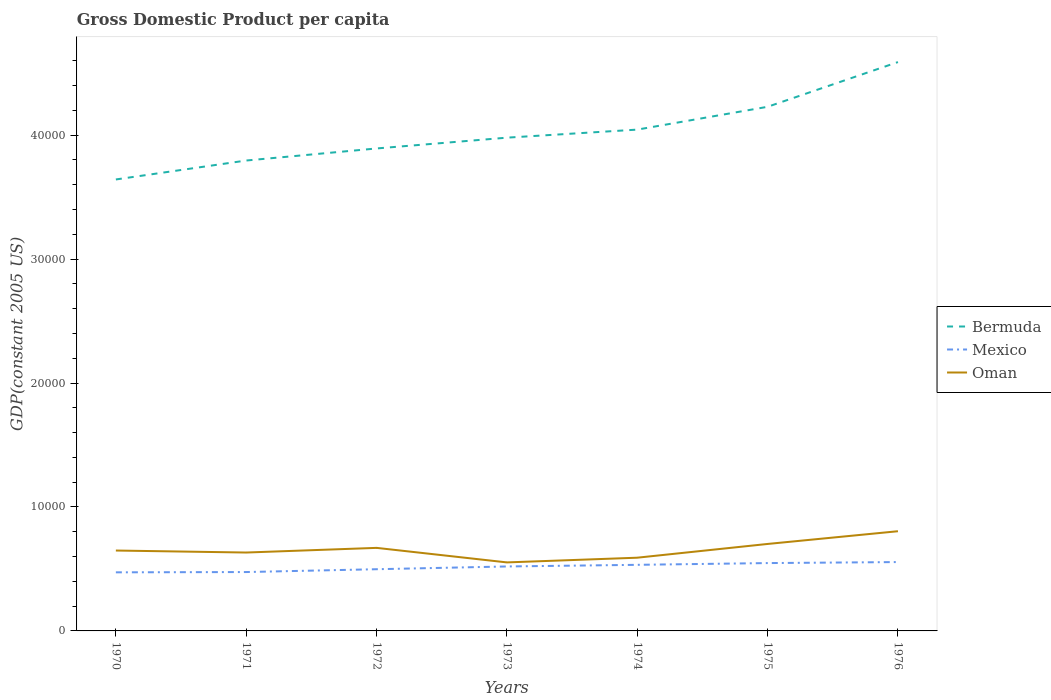Across all years, what is the maximum GDP per capita in Bermuda?
Your answer should be very brief. 3.64e+04. What is the total GDP per capita in Oman in the graph?
Offer a very short reply. 957.95. What is the difference between the highest and the second highest GDP per capita in Bermuda?
Keep it short and to the point. 9469.38. Are the values on the major ticks of Y-axis written in scientific E-notation?
Offer a terse response. No. Where does the legend appear in the graph?
Your response must be concise. Center right. How many legend labels are there?
Keep it short and to the point. 3. How are the legend labels stacked?
Offer a terse response. Vertical. What is the title of the graph?
Provide a short and direct response. Gross Domestic Product per capita. Does "Uganda" appear as one of the legend labels in the graph?
Your answer should be compact. No. What is the label or title of the Y-axis?
Ensure brevity in your answer.  GDP(constant 2005 US). What is the GDP(constant 2005 US) of Bermuda in 1970?
Offer a terse response. 3.64e+04. What is the GDP(constant 2005 US) in Mexico in 1970?
Ensure brevity in your answer.  4726.59. What is the GDP(constant 2005 US) in Oman in 1970?
Your answer should be very brief. 6485.56. What is the GDP(constant 2005 US) in Bermuda in 1971?
Ensure brevity in your answer.  3.80e+04. What is the GDP(constant 2005 US) of Mexico in 1971?
Your answer should be compact. 4750.16. What is the GDP(constant 2005 US) of Oman in 1971?
Provide a succinct answer. 6324.33. What is the GDP(constant 2005 US) of Bermuda in 1972?
Make the answer very short. 3.89e+04. What is the GDP(constant 2005 US) in Mexico in 1972?
Provide a succinct answer. 4977.9. What is the GDP(constant 2005 US) of Oman in 1972?
Your answer should be very brief. 6700.51. What is the GDP(constant 2005 US) of Bermuda in 1973?
Keep it short and to the point. 3.98e+04. What is the GDP(constant 2005 US) of Mexico in 1973?
Provide a succinct answer. 5200.2. What is the GDP(constant 2005 US) in Oman in 1973?
Give a very brief answer. 5527.62. What is the GDP(constant 2005 US) in Bermuda in 1974?
Provide a short and direct response. 4.04e+04. What is the GDP(constant 2005 US) in Mexico in 1974?
Keep it short and to the point. 5332.38. What is the GDP(constant 2005 US) of Oman in 1974?
Give a very brief answer. 5907.33. What is the GDP(constant 2005 US) of Bermuda in 1975?
Keep it short and to the point. 4.23e+04. What is the GDP(constant 2005 US) of Mexico in 1975?
Offer a terse response. 5473.64. What is the GDP(constant 2005 US) in Oman in 1975?
Your response must be concise. 7016.54. What is the GDP(constant 2005 US) of Bermuda in 1976?
Your answer should be very brief. 4.59e+04. What is the GDP(constant 2005 US) in Mexico in 1976?
Offer a terse response. 5555.92. What is the GDP(constant 2005 US) in Oman in 1976?
Give a very brief answer. 8043.76. Across all years, what is the maximum GDP(constant 2005 US) of Bermuda?
Your answer should be compact. 4.59e+04. Across all years, what is the maximum GDP(constant 2005 US) in Mexico?
Provide a succinct answer. 5555.92. Across all years, what is the maximum GDP(constant 2005 US) in Oman?
Provide a short and direct response. 8043.76. Across all years, what is the minimum GDP(constant 2005 US) in Bermuda?
Make the answer very short. 3.64e+04. Across all years, what is the minimum GDP(constant 2005 US) in Mexico?
Ensure brevity in your answer.  4726.59. Across all years, what is the minimum GDP(constant 2005 US) of Oman?
Your answer should be very brief. 5527.62. What is the total GDP(constant 2005 US) of Bermuda in the graph?
Give a very brief answer. 2.82e+05. What is the total GDP(constant 2005 US) in Mexico in the graph?
Offer a very short reply. 3.60e+04. What is the total GDP(constant 2005 US) in Oman in the graph?
Your response must be concise. 4.60e+04. What is the difference between the GDP(constant 2005 US) of Bermuda in 1970 and that in 1971?
Ensure brevity in your answer.  -1528.03. What is the difference between the GDP(constant 2005 US) of Mexico in 1970 and that in 1971?
Your answer should be very brief. -23.57. What is the difference between the GDP(constant 2005 US) of Oman in 1970 and that in 1971?
Your answer should be very brief. 161.23. What is the difference between the GDP(constant 2005 US) of Bermuda in 1970 and that in 1972?
Your response must be concise. -2501.12. What is the difference between the GDP(constant 2005 US) of Mexico in 1970 and that in 1972?
Offer a very short reply. -251.31. What is the difference between the GDP(constant 2005 US) in Oman in 1970 and that in 1972?
Make the answer very short. -214.95. What is the difference between the GDP(constant 2005 US) of Bermuda in 1970 and that in 1973?
Your response must be concise. -3372.31. What is the difference between the GDP(constant 2005 US) in Mexico in 1970 and that in 1973?
Provide a succinct answer. -473.61. What is the difference between the GDP(constant 2005 US) in Oman in 1970 and that in 1973?
Ensure brevity in your answer.  957.95. What is the difference between the GDP(constant 2005 US) in Bermuda in 1970 and that in 1974?
Your response must be concise. -4022.09. What is the difference between the GDP(constant 2005 US) in Mexico in 1970 and that in 1974?
Offer a very short reply. -605.8. What is the difference between the GDP(constant 2005 US) in Oman in 1970 and that in 1974?
Provide a short and direct response. 578.24. What is the difference between the GDP(constant 2005 US) in Bermuda in 1970 and that in 1975?
Your response must be concise. -5862.84. What is the difference between the GDP(constant 2005 US) in Mexico in 1970 and that in 1975?
Make the answer very short. -747.05. What is the difference between the GDP(constant 2005 US) in Oman in 1970 and that in 1975?
Provide a short and direct response. -530.98. What is the difference between the GDP(constant 2005 US) in Bermuda in 1970 and that in 1976?
Provide a short and direct response. -9469.38. What is the difference between the GDP(constant 2005 US) of Mexico in 1970 and that in 1976?
Provide a short and direct response. -829.33. What is the difference between the GDP(constant 2005 US) of Oman in 1970 and that in 1976?
Provide a short and direct response. -1558.2. What is the difference between the GDP(constant 2005 US) of Bermuda in 1971 and that in 1972?
Provide a succinct answer. -973.08. What is the difference between the GDP(constant 2005 US) of Mexico in 1971 and that in 1972?
Your answer should be compact. -227.74. What is the difference between the GDP(constant 2005 US) in Oman in 1971 and that in 1972?
Give a very brief answer. -376.18. What is the difference between the GDP(constant 2005 US) of Bermuda in 1971 and that in 1973?
Your answer should be very brief. -1844.28. What is the difference between the GDP(constant 2005 US) of Mexico in 1971 and that in 1973?
Your response must be concise. -450.04. What is the difference between the GDP(constant 2005 US) in Oman in 1971 and that in 1973?
Ensure brevity in your answer.  796.72. What is the difference between the GDP(constant 2005 US) of Bermuda in 1971 and that in 1974?
Keep it short and to the point. -2494.06. What is the difference between the GDP(constant 2005 US) of Mexico in 1971 and that in 1974?
Ensure brevity in your answer.  -582.22. What is the difference between the GDP(constant 2005 US) in Oman in 1971 and that in 1974?
Give a very brief answer. 417.01. What is the difference between the GDP(constant 2005 US) of Bermuda in 1971 and that in 1975?
Offer a terse response. -4334.81. What is the difference between the GDP(constant 2005 US) in Mexico in 1971 and that in 1975?
Offer a terse response. -723.48. What is the difference between the GDP(constant 2005 US) of Oman in 1971 and that in 1975?
Offer a very short reply. -692.2. What is the difference between the GDP(constant 2005 US) of Bermuda in 1971 and that in 1976?
Your response must be concise. -7941.34. What is the difference between the GDP(constant 2005 US) in Mexico in 1971 and that in 1976?
Keep it short and to the point. -805.76. What is the difference between the GDP(constant 2005 US) of Oman in 1971 and that in 1976?
Keep it short and to the point. -1719.43. What is the difference between the GDP(constant 2005 US) of Bermuda in 1972 and that in 1973?
Provide a short and direct response. -871.19. What is the difference between the GDP(constant 2005 US) of Mexico in 1972 and that in 1973?
Make the answer very short. -222.3. What is the difference between the GDP(constant 2005 US) of Oman in 1972 and that in 1973?
Keep it short and to the point. 1172.9. What is the difference between the GDP(constant 2005 US) in Bermuda in 1972 and that in 1974?
Your answer should be compact. -1520.98. What is the difference between the GDP(constant 2005 US) of Mexico in 1972 and that in 1974?
Make the answer very short. -354.48. What is the difference between the GDP(constant 2005 US) of Oman in 1972 and that in 1974?
Ensure brevity in your answer.  793.19. What is the difference between the GDP(constant 2005 US) in Bermuda in 1972 and that in 1975?
Ensure brevity in your answer.  -3361.73. What is the difference between the GDP(constant 2005 US) in Mexico in 1972 and that in 1975?
Provide a short and direct response. -495.74. What is the difference between the GDP(constant 2005 US) in Oman in 1972 and that in 1975?
Offer a terse response. -316.02. What is the difference between the GDP(constant 2005 US) in Bermuda in 1972 and that in 1976?
Your answer should be very brief. -6968.26. What is the difference between the GDP(constant 2005 US) in Mexico in 1972 and that in 1976?
Your answer should be very brief. -578.02. What is the difference between the GDP(constant 2005 US) of Oman in 1972 and that in 1976?
Your answer should be very brief. -1343.25. What is the difference between the GDP(constant 2005 US) of Bermuda in 1973 and that in 1974?
Your answer should be compact. -649.78. What is the difference between the GDP(constant 2005 US) of Mexico in 1973 and that in 1974?
Your response must be concise. -132.18. What is the difference between the GDP(constant 2005 US) in Oman in 1973 and that in 1974?
Keep it short and to the point. -379.71. What is the difference between the GDP(constant 2005 US) of Bermuda in 1973 and that in 1975?
Provide a succinct answer. -2490.53. What is the difference between the GDP(constant 2005 US) of Mexico in 1973 and that in 1975?
Your answer should be compact. -273.44. What is the difference between the GDP(constant 2005 US) of Oman in 1973 and that in 1975?
Give a very brief answer. -1488.92. What is the difference between the GDP(constant 2005 US) of Bermuda in 1973 and that in 1976?
Your answer should be compact. -6097.07. What is the difference between the GDP(constant 2005 US) in Mexico in 1973 and that in 1976?
Provide a succinct answer. -355.72. What is the difference between the GDP(constant 2005 US) in Oman in 1973 and that in 1976?
Your answer should be very brief. -2516.15. What is the difference between the GDP(constant 2005 US) of Bermuda in 1974 and that in 1975?
Provide a short and direct response. -1840.75. What is the difference between the GDP(constant 2005 US) of Mexico in 1974 and that in 1975?
Offer a very short reply. -141.26. What is the difference between the GDP(constant 2005 US) of Oman in 1974 and that in 1975?
Keep it short and to the point. -1109.21. What is the difference between the GDP(constant 2005 US) of Bermuda in 1974 and that in 1976?
Your response must be concise. -5447.28. What is the difference between the GDP(constant 2005 US) of Mexico in 1974 and that in 1976?
Make the answer very short. -223.54. What is the difference between the GDP(constant 2005 US) in Oman in 1974 and that in 1976?
Give a very brief answer. -2136.44. What is the difference between the GDP(constant 2005 US) of Bermuda in 1975 and that in 1976?
Give a very brief answer. -3606.53. What is the difference between the GDP(constant 2005 US) of Mexico in 1975 and that in 1976?
Keep it short and to the point. -82.28. What is the difference between the GDP(constant 2005 US) in Oman in 1975 and that in 1976?
Your response must be concise. -1027.23. What is the difference between the GDP(constant 2005 US) of Bermuda in 1970 and the GDP(constant 2005 US) of Mexico in 1971?
Offer a very short reply. 3.17e+04. What is the difference between the GDP(constant 2005 US) of Bermuda in 1970 and the GDP(constant 2005 US) of Oman in 1971?
Offer a very short reply. 3.01e+04. What is the difference between the GDP(constant 2005 US) of Mexico in 1970 and the GDP(constant 2005 US) of Oman in 1971?
Keep it short and to the point. -1597.75. What is the difference between the GDP(constant 2005 US) in Bermuda in 1970 and the GDP(constant 2005 US) in Mexico in 1972?
Offer a terse response. 3.14e+04. What is the difference between the GDP(constant 2005 US) of Bermuda in 1970 and the GDP(constant 2005 US) of Oman in 1972?
Your response must be concise. 2.97e+04. What is the difference between the GDP(constant 2005 US) in Mexico in 1970 and the GDP(constant 2005 US) in Oman in 1972?
Keep it short and to the point. -1973.93. What is the difference between the GDP(constant 2005 US) of Bermuda in 1970 and the GDP(constant 2005 US) of Mexico in 1973?
Ensure brevity in your answer.  3.12e+04. What is the difference between the GDP(constant 2005 US) in Bermuda in 1970 and the GDP(constant 2005 US) in Oman in 1973?
Provide a succinct answer. 3.09e+04. What is the difference between the GDP(constant 2005 US) in Mexico in 1970 and the GDP(constant 2005 US) in Oman in 1973?
Offer a terse response. -801.03. What is the difference between the GDP(constant 2005 US) of Bermuda in 1970 and the GDP(constant 2005 US) of Mexico in 1974?
Your answer should be very brief. 3.11e+04. What is the difference between the GDP(constant 2005 US) in Bermuda in 1970 and the GDP(constant 2005 US) in Oman in 1974?
Your response must be concise. 3.05e+04. What is the difference between the GDP(constant 2005 US) of Mexico in 1970 and the GDP(constant 2005 US) of Oman in 1974?
Ensure brevity in your answer.  -1180.74. What is the difference between the GDP(constant 2005 US) in Bermuda in 1970 and the GDP(constant 2005 US) in Mexico in 1975?
Provide a short and direct response. 3.09e+04. What is the difference between the GDP(constant 2005 US) of Bermuda in 1970 and the GDP(constant 2005 US) of Oman in 1975?
Offer a terse response. 2.94e+04. What is the difference between the GDP(constant 2005 US) in Mexico in 1970 and the GDP(constant 2005 US) in Oman in 1975?
Your answer should be compact. -2289.95. What is the difference between the GDP(constant 2005 US) in Bermuda in 1970 and the GDP(constant 2005 US) in Mexico in 1976?
Ensure brevity in your answer.  3.09e+04. What is the difference between the GDP(constant 2005 US) of Bermuda in 1970 and the GDP(constant 2005 US) of Oman in 1976?
Provide a succinct answer. 2.84e+04. What is the difference between the GDP(constant 2005 US) in Mexico in 1970 and the GDP(constant 2005 US) in Oman in 1976?
Provide a succinct answer. -3317.18. What is the difference between the GDP(constant 2005 US) of Bermuda in 1971 and the GDP(constant 2005 US) of Mexico in 1972?
Offer a terse response. 3.30e+04. What is the difference between the GDP(constant 2005 US) in Bermuda in 1971 and the GDP(constant 2005 US) in Oman in 1972?
Your answer should be compact. 3.13e+04. What is the difference between the GDP(constant 2005 US) in Mexico in 1971 and the GDP(constant 2005 US) in Oman in 1972?
Provide a succinct answer. -1950.35. What is the difference between the GDP(constant 2005 US) of Bermuda in 1971 and the GDP(constant 2005 US) of Mexico in 1973?
Keep it short and to the point. 3.28e+04. What is the difference between the GDP(constant 2005 US) in Bermuda in 1971 and the GDP(constant 2005 US) in Oman in 1973?
Your response must be concise. 3.24e+04. What is the difference between the GDP(constant 2005 US) of Mexico in 1971 and the GDP(constant 2005 US) of Oman in 1973?
Provide a short and direct response. -777.46. What is the difference between the GDP(constant 2005 US) in Bermuda in 1971 and the GDP(constant 2005 US) in Mexico in 1974?
Provide a succinct answer. 3.26e+04. What is the difference between the GDP(constant 2005 US) of Bermuda in 1971 and the GDP(constant 2005 US) of Oman in 1974?
Provide a succinct answer. 3.20e+04. What is the difference between the GDP(constant 2005 US) in Mexico in 1971 and the GDP(constant 2005 US) in Oman in 1974?
Ensure brevity in your answer.  -1157.17. What is the difference between the GDP(constant 2005 US) of Bermuda in 1971 and the GDP(constant 2005 US) of Mexico in 1975?
Make the answer very short. 3.25e+04. What is the difference between the GDP(constant 2005 US) of Bermuda in 1971 and the GDP(constant 2005 US) of Oman in 1975?
Offer a very short reply. 3.09e+04. What is the difference between the GDP(constant 2005 US) of Mexico in 1971 and the GDP(constant 2005 US) of Oman in 1975?
Offer a terse response. -2266.38. What is the difference between the GDP(constant 2005 US) of Bermuda in 1971 and the GDP(constant 2005 US) of Mexico in 1976?
Offer a very short reply. 3.24e+04. What is the difference between the GDP(constant 2005 US) of Bermuda in 1971 and the GDP(constant 2005 US) of Oman in 1976?
Your answer should be compact. 2.99e+04. What is the difference between the GDP(constant 2005 US) of Mexico in 1971 and the GDP(constant 2005 US) of Oman in 1976?
Make the answer very short. -3293.6. What is the difference between the GDP(constant 2005 US) of Bermuda in 1972 and the GDP(constant 2005 US) of Mexico in 1973?
Provide a short and direct response. 3.37e+04. What is the difference between the GDP(constant 2005 US) of Bermuda in 1972 and the GDP(constant 2005 US) of Oman in 1973?
Your answer should be very brief. 3.34e+04. What is the difference between the GDP(constant 2005 US) in Mexico in 1972 and the GDP(constant 2005 US) in Oman in 1973?
Keep it short and to the point. -549.72. What is the difference between the GDP(constant 2005 US) in Bermuda in 1972 and the GDP(constant 2005 US) in Mexico in 1974?
Offer a terse response. 3.36e+04. What is the difference between the GDP(constant 2005 US) of Bermuda in 1972 and the GDP(constant 2005 US) of Oman in 1974?
Ensure brevity in your answer.  3.30e+04. What is the difference between the GDP(constant 2005 US) in Mexico in 1972 and the GDP(constant 2005 US) in Oman in 1974?
Provide a short and direct response. -929.43. What is the difference between the GDP(constant 2005 US) of Bermuda in 1972 and the GDP(constant 2005 US) of Mexico in 1975?
Your answer should be very brief. 3.35e+04. What is the difference between the GDP(constant 2005 US) of Bermuda in 1972 and the GDP(constant 2005 US) of Oman in 1975?
Make the answer very short. 3.19e+04. What is the difference between the GDP(constant 2005 US) of Mexico in 1972 and the GDP(constant 2005 US) of Oman in 1975?
Keep it short and to the point. -2038.64. What is the difference between the GDP(constant 2005 US) of Bermuda in 1972 and the GDP(constant 2005 US) of Mexico in 1976?
Offer a terse response. 3.34e+04. What is the difference between the GDP(constant 2005 US) of Bermuda in 1972 and the GDP(constant 2005 US) of Oman in 1976?
Your answer should be very brief. 3.09e+04. What is the difference between the GDP(constant 2005 US) of Mexico in 1972 and the GDP(constant 2005 US) of Oman in 1976?
Your answer should be very brief. -3065.87. What is the difference between the GDP(constant 2005 US) of Bermuda in 1973 and the GDP(constant 2005 US) of Mexico in 1974?
Keep it short and to the point. 3.45e+04. What is the difference between the GDP(constant 2005 US) in Bermuda in 1973 and the GDP(constant 2005 US) in Oman in 1974?
Your response must be concise. 3.39e+04. What is the difference between the GDP(constant 2005 US) of Mexico in 1973 and the GDP(constant 2005 US) of Oman in 1974?
Offer a terse response. -707.13. What is the difference between the GDP(constant 2005 US) of Bermuda in 1973 and the GDP(constant 2005 US) of Mexico in 1975?
Provide a succinct answer. 3.43e+04. What is the difference between the GDP(constant 2005 US) of Bermuda in 1973 and the GDP(constant 2005 US) of Oman in 1975?
Your answer should be compact. 3.28e+04. What is the difference between the GDP(constant 2005 US) of Mexico in 1973 and the GDP(constant 2005 US) of Oman in 1975?
Provide a short and direct response. -1816.34. What is the difference between the GDP(constant 2005 US) in Bermuda in 1973 and the GDP(constant 2005 US) in Mexico in 1976?
Offer a very short reply. 3.42e+04. What is the difference between the GDP(constant 2005 US) of Bermuda in 1973 and the GDP(constant 2005 US) of Oman in 1976?
Ensure brevity in your answer.  3.18e+04. What is the difference between the GDP(constant 2005 US) of Mexico in 1973 and the GDP(constant 2005 US) of Oman in 1976?
Ensure brevity in your answer.  -2843.57. What is the difference between the GDP(constant 2005 US) of Bermuda in 1974 and the GDP(constant 2005 US) of Mexico in 1975?
Ensure brevity in your answer.  3.50e+04. What is the difference between the GDP(constant 2005 US) in Bermuda in 1974 and the GDP(constant 2005 US) in Oman in 1975?
Your answer should be very brief. 3.34e+04. What is the difference between the GDP(constant 2005 US) in Mexico in 1974 and the GDP(constant 2005 US) in Oman in 1975?
Ensure brevity in your answer.  -1684.16. What is the difference between the GDP(constant 2005 US) in Bermuda in 1974 and the GDP(constant 2005 US) in Mexico in 1976?
Offer a very short reply. 3.49e+04. What is the difference between the GDP(constant 2005 US) in Bermuda in 1974 and the GDP(constant 2005 US) in Oman in 1976?
Provide a short and direct response. 3.24e+04. What is the difference between the GDP(constant 2005 US) of Mexico in 1974 and the GDP(constant 2005 US) of Oman in 1976?
Provide a succinct answer. -2711.38. What is the difference between the GDP(constant 2005 US) in Bermuda in 1975 and the GDP(constant 2005 US) in Mexico in 1976?
Your response must be concise. 3.67e+04. What is the difference between the GDP(constant 2005 US) in Bermuda in 1975 and the GDP(constant 2005 US) in Oman in 1976?
Provide a succinct answer. 3.42e+04. What is the difference between the GDP(constant 2005 US) of Mexico in 1975 and the GDP(constant 2005 US) of Oman in 1976?
Offer a very short reply. -2570.13. What is the average GDP(constant 2005 US) of Bermuda per year?
Offer a very short reply. 4.02e+04. What is the average GDP(constant 2005 US) of Mexico per year?
Keep it short and to the point. 5145.25. What is the average GDP(constant 2005 US) in Oman per year?
Provide a short and direct response. 6572.24. In the year 1970, what is the difference between the GDP(constant 2005 US) of Bermuda and GDP(constant 2005 US) of Mexico?
Offer a terse response. 3.17e+04. In the year 1970, what is the difference between the GDP(constant 2005 US) in Bermuda and GDP(constant 2005 US) in Oman?
Keep it short and to the point. 2.99e+04. In the year 1970, what is the difference between the GDP(constant 2005 US) of Mexico and GDP(constant 2005 US) of Oman?
Keep it short and to the point. -1758.98. In the year 1971, what is the difference between the GDP(constant 2005 US) of Bermuda and GDP(constant 2005 US) of Mexico?
Offer a very short reply. 3.32e+04. In the year 1971, what is the difference between the GDP(constant 2005 US) in Bermuda and GDP(constant 2005 US) in Oman?
Offer a very short reply. 3.16e+04. In the year 1971, what is the difference between the GDP(constant 2005 US) of Mexico and GDP(constant 2005 US) of Oman?
Offer a very short reply. -1574.17. In the year 1972, what is the difference between the GDP(constant 2005 US) in Bermuda and GDP(constant 2005 US) in Mexico?
Ensure brevity in your answer.  3.39e+04. In the year 1972, what is the difference between the GDP(constant 2005 US) in Bermuda and GDP(constant 2005 US) in Oman?
Your answer should be compact. 3.22e+04. In the year 1972, what is the difference between the GDP(constant 2005 US) of Mexico and GDP(constant 2005 US) of Oman?
Your response must be concise. -1722.62. In the year 1973, what is the difference between the GDP(constant 2005 US) of Bermuda and GDP(constant 2005 US) of Mexico?
Keep it short and to the point. 3.46e+04. In the year 1973, what is the difference between the GDP(constant 2005 US) of Bermuda and GDP(constant 2005 US) of Oman?
Provide a short and direct response. 3.43e+04. In the year 1973, what is the difference between the GDP(constant 2005 US) of Mexico and GDP(constant 2005 US) of Oman?
Offer a terse response. -327.42. In the year 1974, what is the difference between the GDP(constant 2005 US) of Bermuda and GDP(constant 2005 US) of Mexico?
Make the answer very short. 3.51e+04. In the year 1974, what is the difference between the GDP(constant 2005 US) in Bermuda and GDP(constant 2005 US) in Oman?
Offer a terse response. 3.45e+04. In the year 1974, what is the difference between the GDP(constant 2005 US) in Mexico and GDP(constant 2005 US) in Oman?
Offer a very short reply. -574.95. In the year 1975, what is the difference between the GDP(constant 2005 US) of Bermuda and GDP(constant 2005 US) of Mexico?
Provide a succinct answer. 3.68e+04. In the year 1975, what is the difference between the GDP(constant 2005 US) in Bermuda and GDP(constant 2005 US) in Oman?
Ensure brevity in your answer.  3.53e+04. In the year 1975, what is the difference between the GDP(constant 2005 US) of Mexico and GDP(constant 2005 US) of Oman?
Your response must be concise. -1542.9. In the year 1976, what is the difference between the GDP(constant 2005 US) in Bermuda and GDP(constant 2005 US) in Mexico?
Ensure brevity in your answer.  4.03e+04. In the year 1976, what is the difference between the GDP(constant 2005 US) in Bermuda and GDP(constant 2005 US) in Oman?
Provide a short and direct response. 3.78e+04. In the year 1976, what is the difference between the GDP(constant 2005 US) in Mexico and GDP(constant 2005 US) in Oman?
Give a very brief answer. -2487.84. What is the ratio of the GDP(constant 2005 US) in Bermuda in 1970 to that in 1971?
Offer a very short reply. 0.96. What is the ratio of the GDP(constant 2005 US) in Mexico in 1970 to that in 1971?
Keep it short and to the point. 0.99. What is the ratio of the GDP(constant 2005 US) of Oman in 1970 to that in 1971?
Ensure brevity in your answer.  1.03. What is the ratio of the GDP(constant 2005 US) in Bermuda in 1970 to that in 1972?
Keep it short and to the point. 0.94. What is the ratio of the GDP(constant 2005 US) of Mexico in 1970 to that in 1972?
Provide a short and direct response. 0.95. What is the ratio of the GDP(constant 2005 US) in Oman in 1970 to that in 1972?
Offer a very short reply. 0.97. What is the ratio of the GDP(constant 2005 US) in Bermuda in 1970 to that in 1973?
Provide a short and direct response. 0.92. What is the ratio of the GDP(constant 2005 US) in Mexico in 1970 to that in 1973?
Provide a succinct answer. 0.91. What is the ratio of the GDP(constant 2005 US) of Oman in 1970 to that in 1973?
Your answer should be very brief. 1.17. What is the ratio of the GDP(constant 2005 US) in Bermuda in 1970 to that in 1974?
Your answer should be compact. 0.9. What is the ratio of the GDP(constant 2005 US) in Mexico in 1970 to that in 1974?
Your response must be concise. 0.89. What is the ratio of the GDP(constant 2005 US) of Oman in 1970 to that in 1974?
Your answer should be compact. 1.1. What is the ratio of the GDP(constant 2005 US) of Bermuda in 1970 to that in 1975?
Offer a very short reply. 0.86. What is the ratio of the GDP(constant 2005 US) of Mexico in 1970 to that in 1975?
Provide a short and direct response. 0.86. What is the ratio of the GDP(constant 2005 US) in Oman in 1970 to that in 1975?
Provide a succinct answer. 0.92. What is the ratio of the GDP(constant 2005 US) of Bermuda in 1970 to that in 1976?
Keep it short and to the point. 0.79. What is the ratio of the GDP(constant 2005 US) in Mexico in 1970 to that in 1976?
Provide a short and direct response. 0.85. What is the ratio of the GDP(constant 2005 US) of Oman in 1970 to that in 1976?
Provide a succinct answer. 0.81. What is the ratio of the GDP(constant 2005 US) in Bermuda in 1971 to that in 1972?
Give a very brief answer. 0.97. What is the ratio of the GDP(constant 2005 US) of Mexico in 1971 to that in 1972?
Your answer should be compact. 0.95. What is the ratio of the GDP(constant 2005 US) of Oman in 1971 to that in 1972?
Offer a terse response. 0.94. What is the ratio of the GDP(constant 2005 US) of Bermuda in 1971 to that in 1973?
Your answer should be very brief. 0.95. What is the ratio of the GDP(constant 2005 US) in Mexico in 1971 to that in 1973?
Offer a very short reply. 0.91. What is the ratio of the GDP(constant 2005 US) of Oman in 1971 to that in 1973?
Provide a succinct answer. 1.14. What is the ratio of the GDP(constant 2005 US) in Bermuda in 1971 to that in 1974?
Offer a very short reply. 0.94. What is the ratio of the GDP(constant 2005 US) in Mexico in 1971 to that in 1974?
Provide a short and direct response. 0.89. What is the ratio of the GDP(constant 2005 US) in Oman in 1971 to that in 1974?
Offer a terse response. 1.07. What is the ratio of the GDP(constant 2005 US) in Bermuda in 1971 to that in 1975?
Offer a very short reply. 0.9. What is the ratio of the GDP(constant 2005 US) in Mexico in 1971 to that in 1975?
Provide a succinct answer. 0.87. What is the ratio of the GDP(constant 2005 US) of Oman in 1971 to that in 1975?
Your answer should be very brief. 0.9. What is the ratio of the GDP(constant 2005 US) of Bermuda in 1971 to that in 1976?
Offer a very short reply. 0.83. What is the ratio of the GDP(constant 2005 US) of Mexico in 1971 to that in 1976?
Offer a very short reply. 0.85. What is the ratio of the GDP(constant 2005 US) in Oman in 1971 to that in 1976?
Your answer should be very brief. 0.79. What is the ratio of the GDP(constant 2005 US) in Bermuda in 1972 to that in 1973?
Provide a succinct answer. 0.98. What is the ratio of the GDP(constant 2005 US) of Mexico in 1972 to that in 1973?
Your answer should be very brief. 0.96. What is the ratio of the GDP(constant 2005 US) of Oman in 1972 to that in 1973?
Your response must be concise. 1.21. What is the ratio of the GDP(constant 2005 US) of Bermuda in 1972 to that in 1974?
Offer a terse response. 0.96. What is the ratio of the GDP(constant 2005 US) of Mexico in 1972 to that in 1974?
Keep it short and to the point. 0.93. What is the ratio of the GDP(constant 2005 US) of Oman in 1972 to that in 1974?
Offer a very short reply. 1.13. What is the ratio of the GDP(constant 2005 US) in Bermuda in 1972 to that in 1975?
Your answer should be compact. 0.92. What is the ratio of the GDP(constant 2005 US) of Mexico in 1972 to that in 1975?
Give a very brief answer. 0.91. What is the ratio of the GDP(constant 2005 US) of Oman in 1972 to that in 1975?
Ensure brevity in your answer.  0.95. What is the ratio of the GDP(constant 2005 US) of Bermuda in 1972 to that in 1976?
Provide a succinct answer. 0.85. What is the ratio of the GDP(constant 2005 US) of Mexico in 1972 to that in 1976?
Give a very brief answer. 0.9. What is the ratio of the GDP(constant 2005 US) in Oman in 1972 to that in 1976?
Your answer should be very brief. 0.83. What is the ratio of the GDP(constant 2005 US) of Bermuda in 1973 to that in 1974?
Keep it short and to the point. 0.98. What is the ratio of the GDP(constant 2005 US) of Mexico in 1973 to that in 1974?
Make the answer very short. 0.98. What is the ratio of the GDP(constant 2005 US) of Oman in 1973 to that in 1974?
Provide a short and direct response. 0.94. What is the ratio of the GDP(constant 2005 US) in Bermuda in 1973 to that in 1975?
Offer a very short reply. 0.94. What is the ratio of the GDP(constant 2005 US) in Oman in 1973 to that in 1975?
Keep it short and to the point. 0.79. What is the ratio of the GDP(constant 2005 US) of Bermuda in 1973 to that in 1976?
Keep it short and to the point. 0.87. What is the ratio of the GDP(constant 2005 US) of Mexico in 1973 to that in 1976?
Provide a short and direct response. 0.94. What is the ratio of the GDP(constant 2005 US) in Oman in 1973 to that in 1976?
Provide a short and direct response. 0.69. What is the ratio of the GDP(constant 2005 US) in Bermuda in 1974 to that in 1975?
Your response must be concise. 0.96. What is the ratio of the GDP(constant 2005 US) of Mexico in 1974 to that in 1975?
Your answer should be very brief. 0.97. What is the ratio of the GDP(constant 2005 US) in Oman in 1974 to that in 1975?
Offer a very short reply. 0.84. What is the ratio of the GDP(constant 2005 US) in Bermuda in 1974 to that in 1976?
Provide a short and direct response. 0.88. What is the ratio of the GDP(constant 2005 US) in Mexico in 1974 to that in 1976?
Provide a short and direct response. 0.96. What is the ratio of the GDP(constant 2005 US) in Oman in 1974 to that in 1976?
Keep it short and to the point. 0.73. What is the ratio of the GDP(constant 2005 US) of Bermuda in 1975 to that in 1976?
Your answer should be compact. 0.92. What is the ratio of the GDP(constant 2005 US) in Mexico in 1975 to that in 1976?
Make the answer very short. 0.99. What is the ratio of the GDP(constant 2005 US) of Oman in 1975 to that in 1976?
Offer a terse response. 0.87. What is the difference between the highest and the second highest GDP(constant 2005 US) of Bermuda?
Ensure brevity in your answer.  3606.53. What is the difference between the highest and the second highest GDP(constant 2005 US) in Mexico?
Provide a succinct answer. 82.28. What is the difference between the highest and the second highest GDP(constant 2005 US) of Oman?
Provide a short and direct response. 1027.23. What is the difference between the highest and the lowest GDP(constant 2005 US) in Bermuda?
Your answer should be compact. 9469.38. What is the difference between the highest and the lowest GDP(constant 2005 US) in Mexico?
Your answer should be compact. 829.33. What is the difference between the highest and the lowest GDP(constant 2005 US) in Oman?
Keep it short and to the point. 2516.15. 